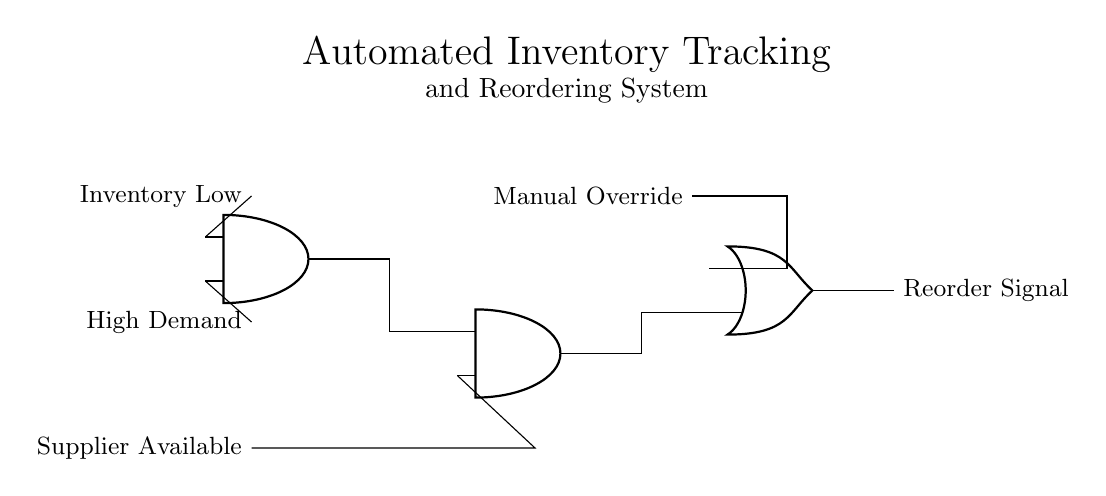What do the input signals represent? The input signals are "Inventory Low," "High Demand," and "Supplier Available," which indicate the status of the inventory, market demand, and supplier capacity, respectively.
Answer: Inventory Low, High Demand, Supplier Available How many AND gates are present in the circuit? There are two AND gates in the circuit: one combines "Inventory Low" and "High Demand," and the other combines the output of the first AND gate with "Supplier Available."
Answer: 2 What is the purpose of the OR gate in this circuit? The OR gate allows for a "Manual Override" input, enabling an alternative way to generate the reorder signal regardless of the automatic logic from the AND gates.
Answer: Manual Override What happens if both "Inventory Low" and "Supplier Available" are true? If both signals are true, the first AND gate will output true, and if "High Demand" is also true, the second AND gate will also output true, leading to a reorder signal unless manually overridden.
Answer: Reorder Signal What is the output of the circuit called? The output of the circuit is referred to as the "Reorder Signal," which triggers the ordering process based on the inputs' status.
Answer: Reorder Signal 